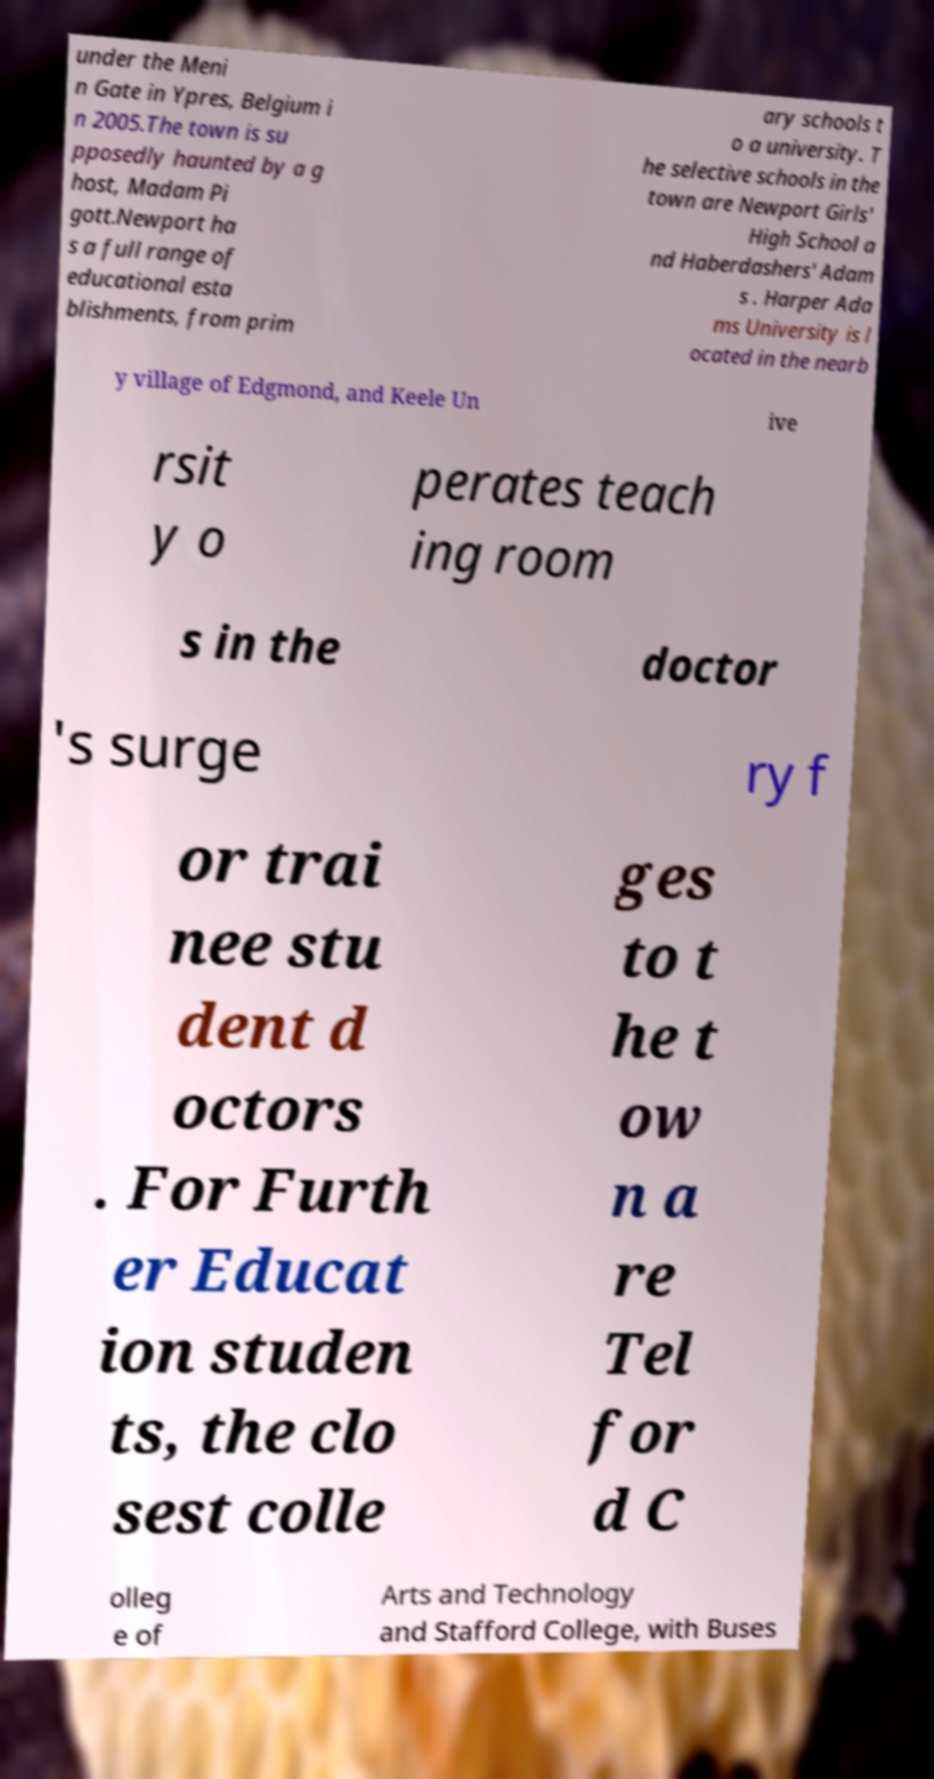Please read and relay the text visible in this image. What does it say? under the Meni n Gate in Ypres, Belgium i n 2005.The town is su pposedly haunted by a g host, Madam Pi gott.Newport ha s a full range of educational esta blishments, from prim ary schools t o a university. T he selective schools in the town are Newport Girls' High School a nd Haberdashers' Adam s . Harper Ada ms University is l ocated in the nearb y village of Edgmond, and Keele Un ive rsit y o perates teach ing room s in the doctor 's surge ry f or trai nee stu dent d octors . For Furth er Educat ion studen ts, the clo sest colle ges to t he t ow n a re Tel for d C olleg e of Arts and Technology and Stafford College, with Buses 